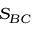<formula> <loc_0><loc_0><loc_500><loc_500>S _ { B C }</formula> 